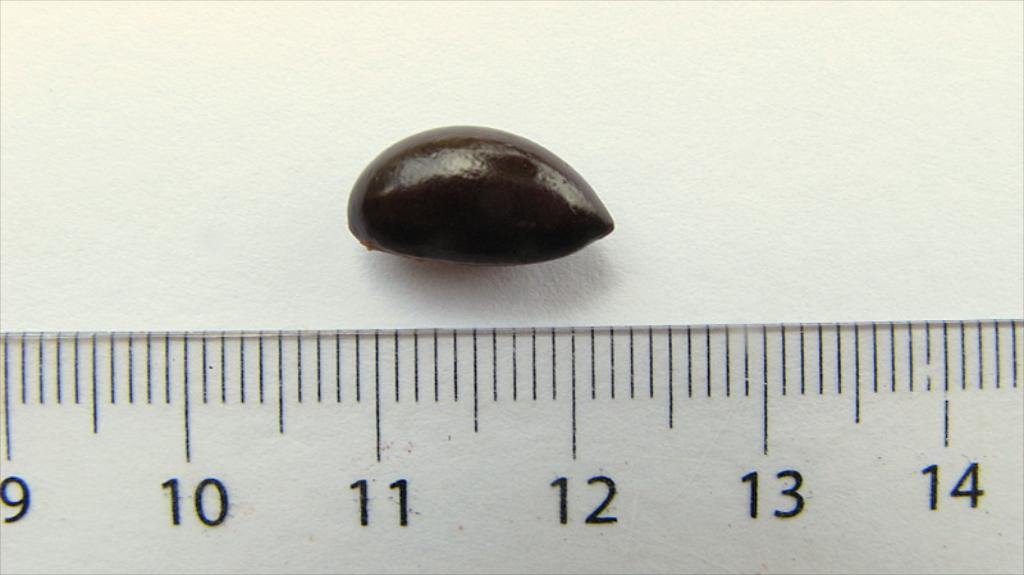What type of elements can be seen in the image? There are numbers and lines in the image. Can you describe the object on the wall in the image? There is an object on a wall in the image, but its specific details are not mentioned in the provided facts. What might the lines and numbers be used for in the image? The purpose of the lines and numbers in the image is not specified in the provided facts. What type of silk fabric is draped over the actor in the image? There is no actor or silk fabric present in the image. How many beads are strung together on the necklace worn by the actor in the image? There is no actor or necklace present in the image. 